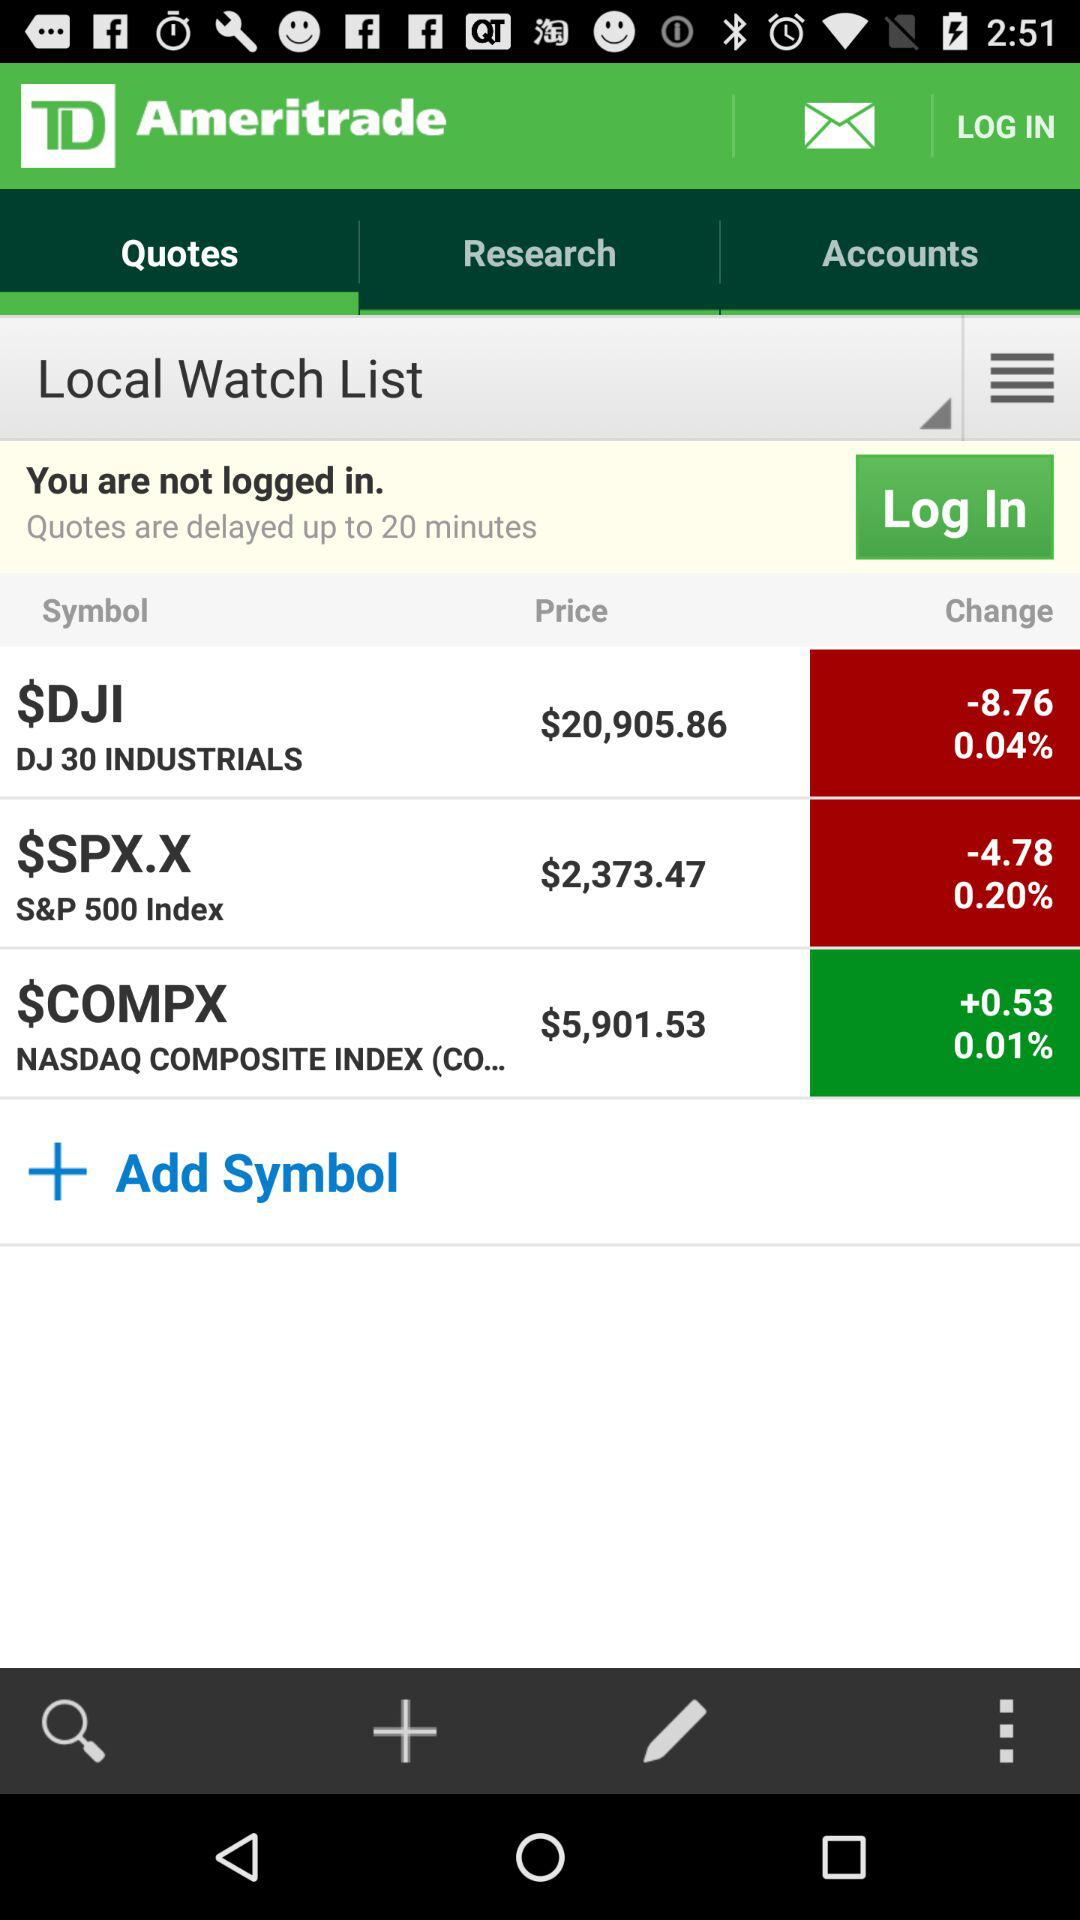What is the symbol for "S&P 500 Index"? The symbol for "S&P 500 Index" is $SPX.X. 